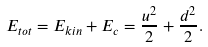Convert formula to latex. <formula><loc_0><loc_0><loc_500><loc_500>E _ { t o t } = E _ { k i n } + E _ { c } = \frac { u ^ { 2 } } { 2 } + \frac { d ^ { 2 } } { 2 } .</formula> 